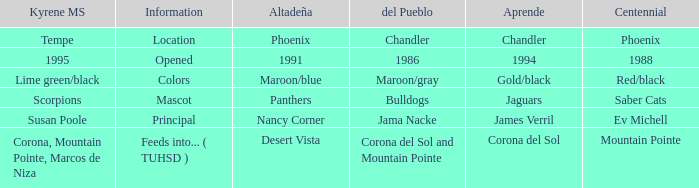Which Centennial has a Altadeña of panthers? Saber Cats. 